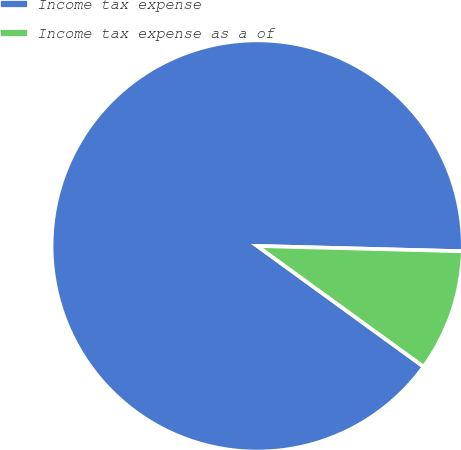<chart> <loc_0><loc_0><loc_500><loc_500><pie_chart><fcel>Income tax expense<fcel>Income tax expense as a of<nl><fcel>90.42%<fcel>9.58%<nl></chart> 